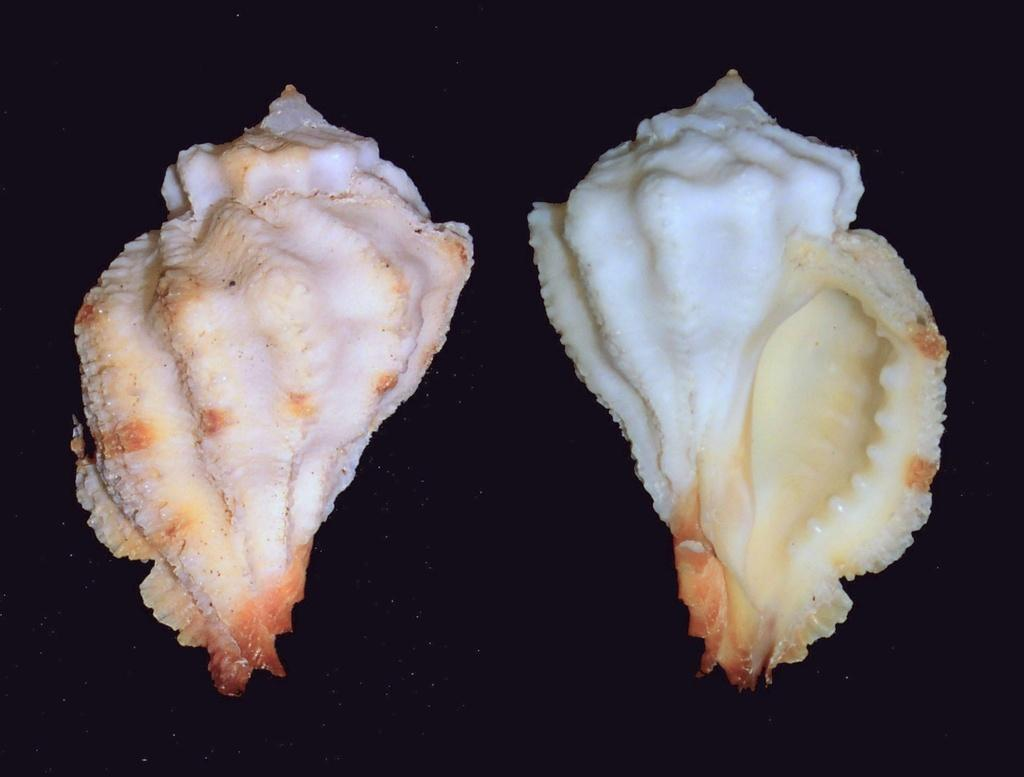What objects can be seen in the image? There are two seashells in the image. Can you describe the seashells in more detail? Unfortunately, the image does not provide enough detail to describe the seashells further. What might be the origin of the seashells? The seashells might have come from a beach or ocean, but the image does not provide any information about their origin. What type of fuel is being used by the hole in the image? There is no hole or fuel present in the image; it only features two seashells. 